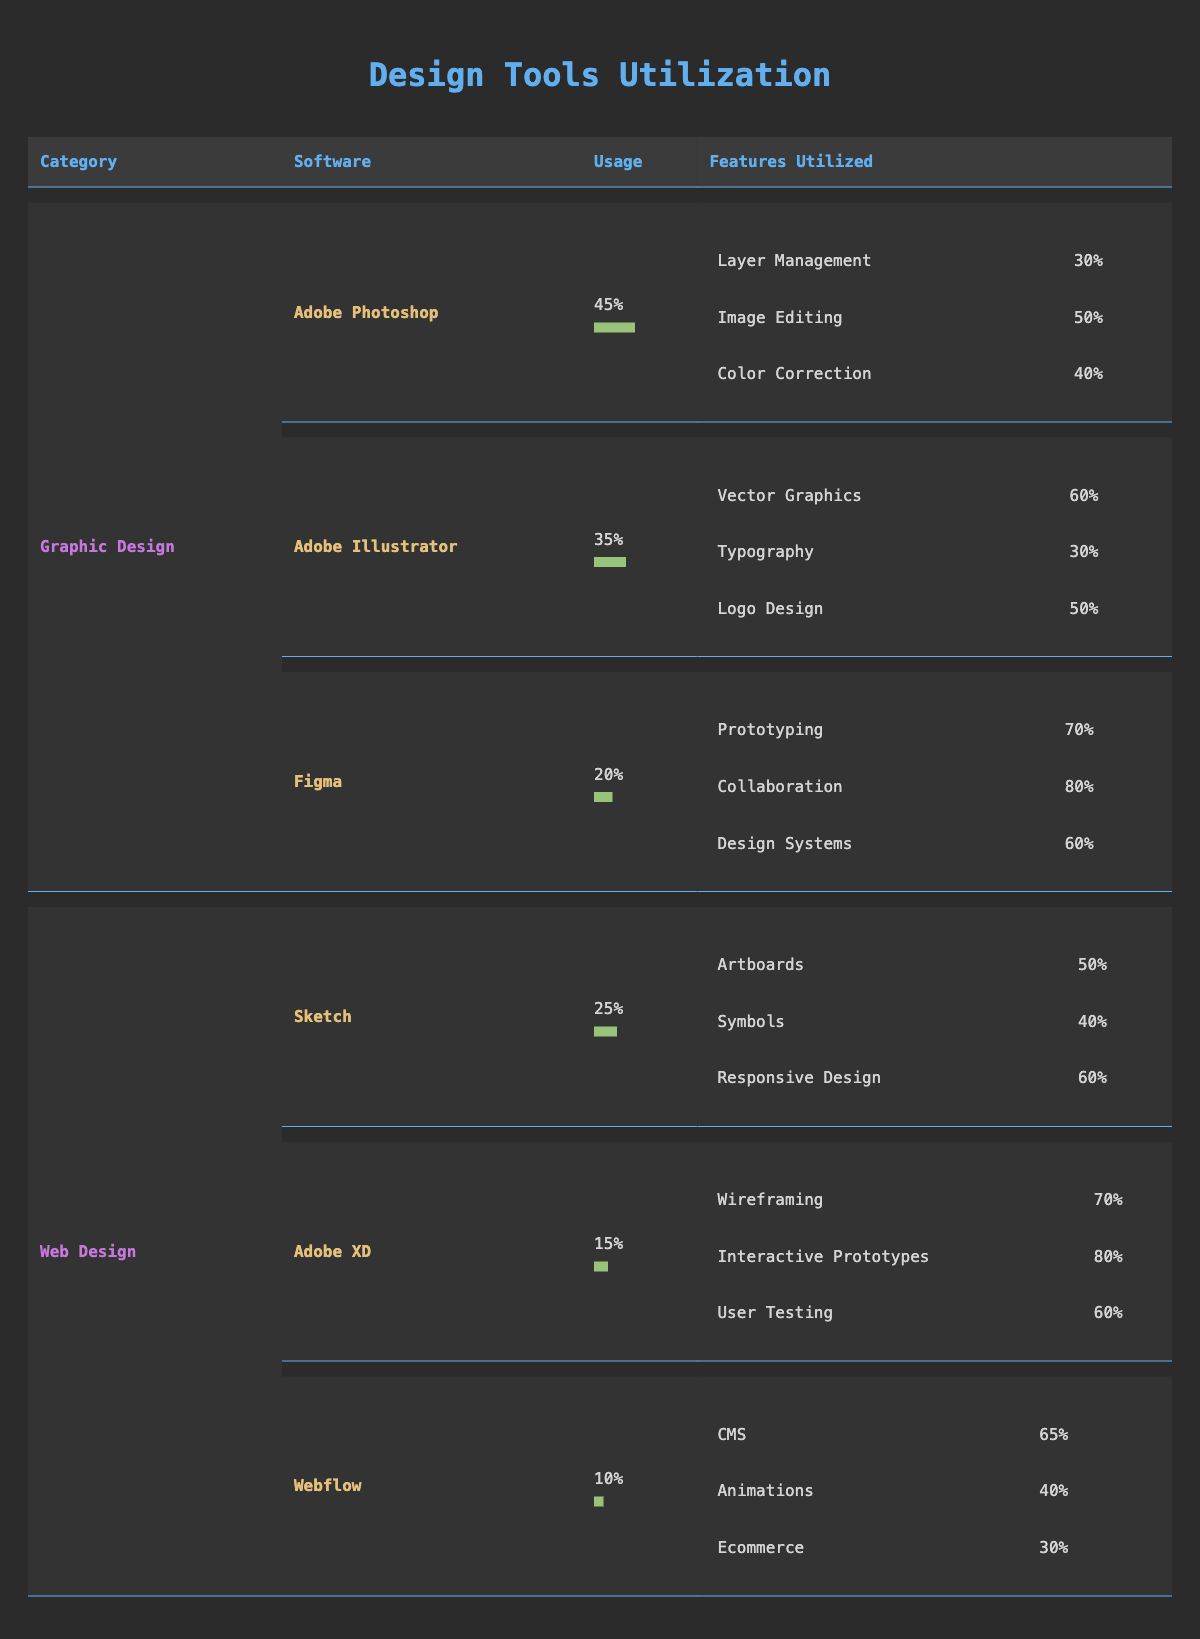What is the most utilized software in Graphic Design? The software with the highest usage percentage in Graphic Design is Adobe Photoshop, which has a usage percentage of 45%.
Answer: Adobe Photoshop What percentage usage does Figma have compared to Adobe Illustrator? Figma has a usage percentage of 20%, while Adobe Illustrator has 35%. The difference is 35 - 20 = 15, so Figma has 15% lower usage than Adobe Illustrator.
Answer: 15% lower Which software has the highest utilization for Prototyping? In the Figma section, Prototyping has the highest utilization at 70%.
Answer: Figma Is Webflow utilized more than Adobe XD? Webflow has a usage percentage of 10%, while Adobe XD has a usage percentage of 15%. Since 10 is less than 15, Webflow is not utilized more than Adobe XD.
Answer: No What is the average usage percentage of all Graphic Design software? The usage percentages for Graphic Design software are 45% (Photoshop), 35% (Illustrator), and 20% (Figma). Adding these gives us 45 + 35 + 20 = 100. To find the average, divide by 3, which gives us 100 / 3 ≈ 33.33%.
Answer: 33.33% 